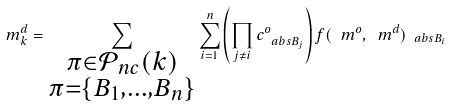Convert formula to latex. <formula><loc_0><loc_0><loc_500><loc_500>m _ { k } ^ { d } = \sum _ { \substack { \pi \in \mathcal { P } _ { n c } ( k ) \\ \pi = \{ B _ { 1 } , \dots , B _ { n } \} } } \sum _ { i = 1 } ^ { n } \left ( \prod _ { j \neq i } c _ { \ a b s { B _ { j } } } ^ { o } \right ) f ( \ m ^ { o } , \ m ^ { d } ) _ { \ a b s { B _ { i } } }</formula> 